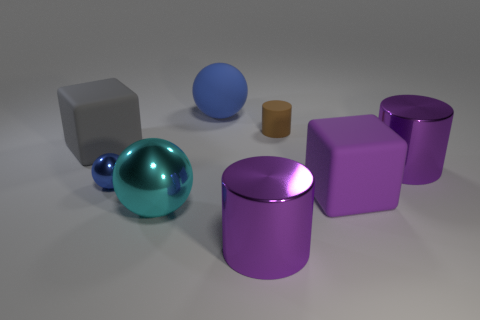Can you describe the lighting in the image? The lighting in the image seems to be diffuse and soft, coming from above, resulting in gentle shadows beneath the objects. Does the lighting affect the appearance of the objects in any particular way? Yes, the soft lighting enhances the objects' three-dimensionality and makes the reflective properties of the surfaces more pronounced. 